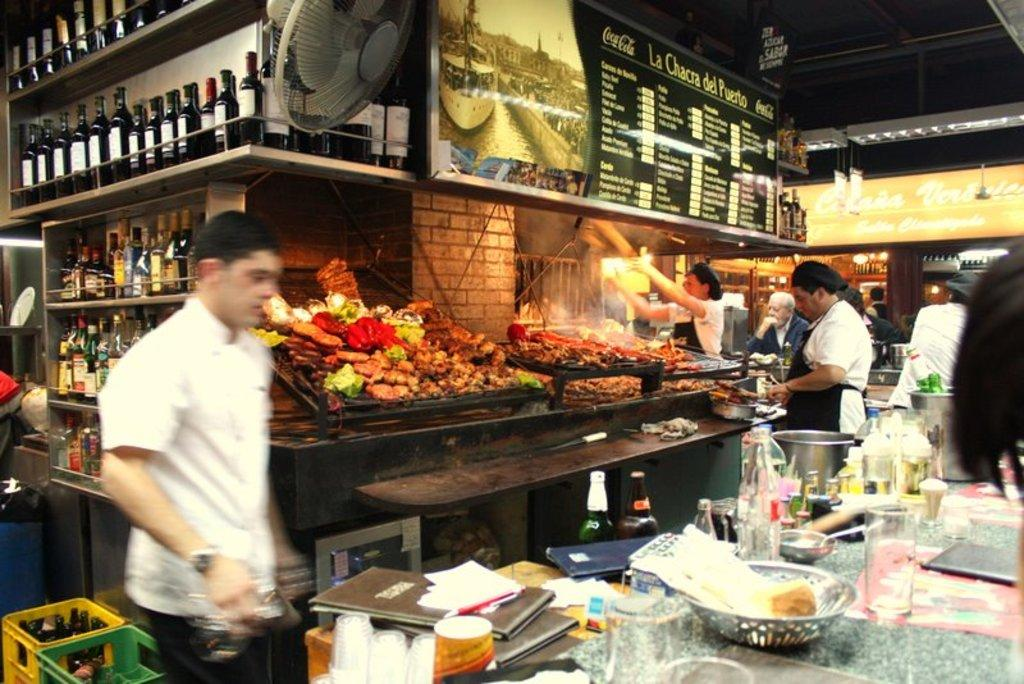What objects can be seen in the image? There are bottles, a board, a fan, food, people, glasses, and additional things on the table in the image. Can you describe the board in the image? The board is a flat surface that may be used for various purposes, such as writing or displaying items. What is the purpose of the fan in the image? The fan is likely used for cooling the room or providing ventilation. What type of food is visible in the image? The specific type of food cannot be determined from the image, but it appears to be a meal or snack. How many glasses are on the table in the image? There are glasses on the table in the image. How many bottles are on the table in the image? There are bottles on the table in the image. What type of friction can be seen between the donkey and the form in the image? There is no donkey or form present in the image, so it is not possible to determine any friction between them. 